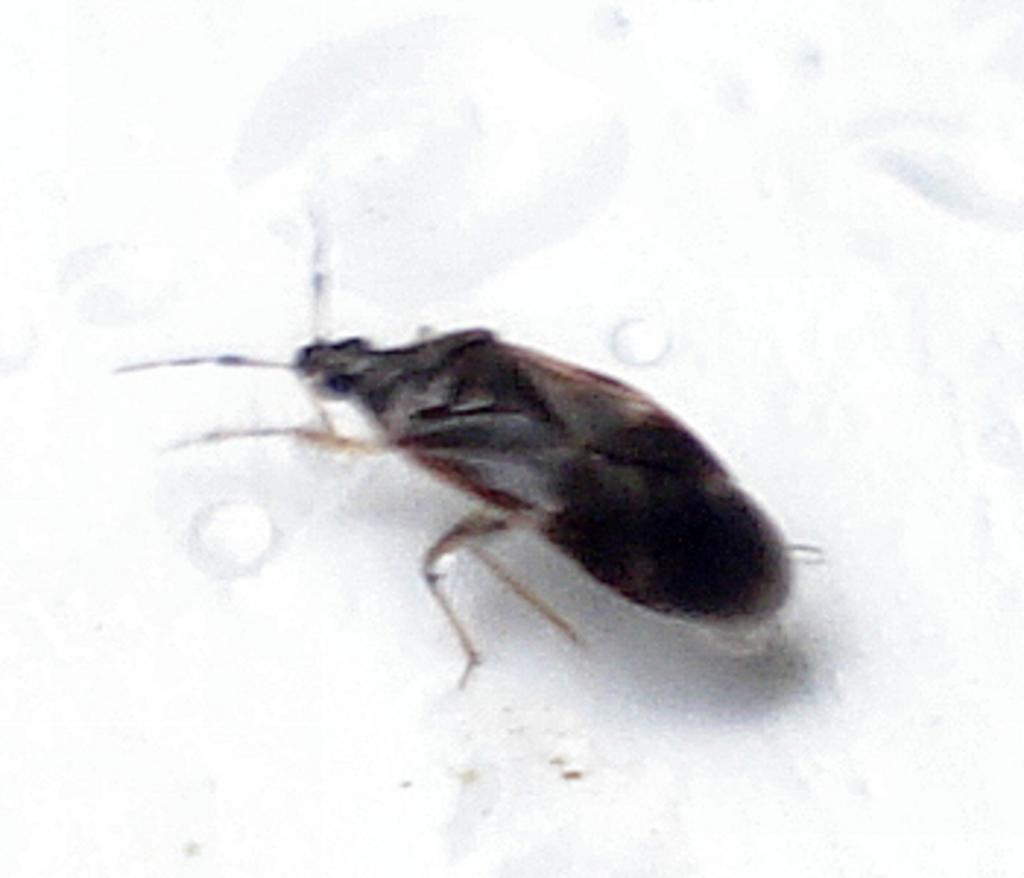Can you describe this image briefly? This is a zoomed in picture. In the center there is an insect seems to be standing on the top of an object. 